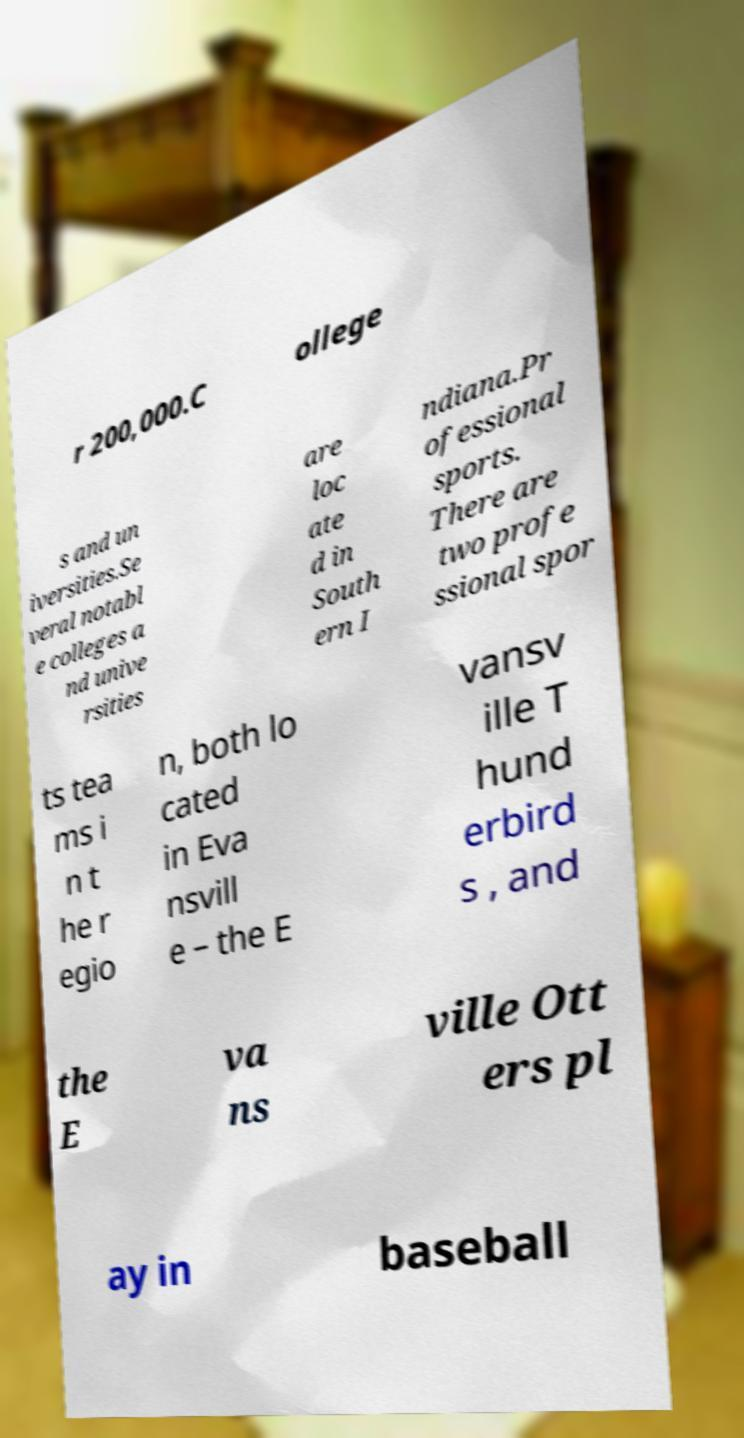What messages or text are displayed in this image? I need them in a readable, typed format. r 200,000.C ollege s and un iversities.Se veral notabl e colleges a nd unive rsities are loc ate d in South ern I ndiana.Pr ofessional sports. There are two profe ssional spor ts tea ms i n t he r egio n, both lo cated in Eva nsvill e – the E vansv ille T hund erbird s , and the E va ns ville Ott ers pl ay in baseball 